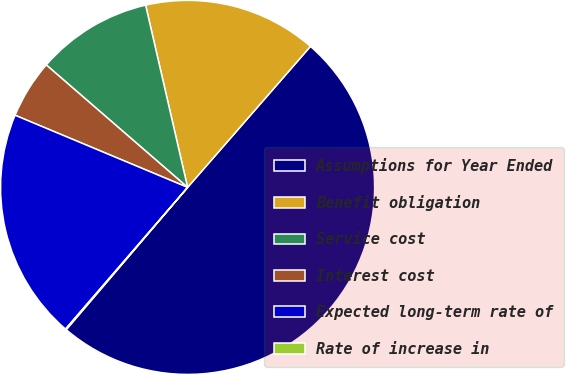Convert chart. <chart><loc_0><loc_0><loc_500><loc_500><pie_chart><fcel>Assumptions for Year Ended<fcel>Benefit obligation<fcel>Service cost<fcel>Interest cost<fcel>Expected long-term rate of<fcel>Rate of increase in<nl><fcel>49.83%<fcel>15.01%<fcel>10.03%<fcel>5.06%<fcel>19.98%<fcel>0.08%<nl></chart> 